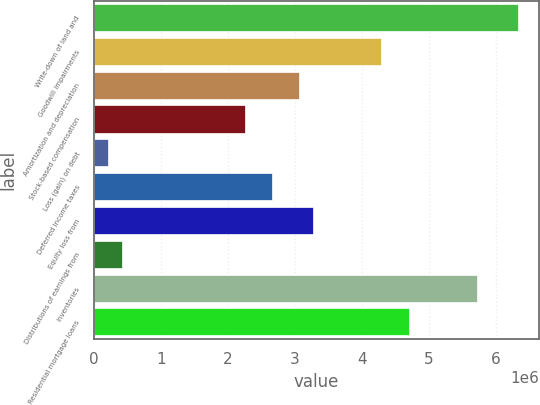Convert chart. <chart><loc_0><loc_0><loc_500><loc_500><bar_chart><fcel>Write-down of land and<fcel>Goodwill impairments<fcel>Amortization and depreciation<fcel>Stock-based compensation<fcel>Loss (gain) on debt<fcel>Deferred income taxes<fcel>Equity loss from<fcel>Distributions of earnings from<fcel>Inventories<fcel>Residential mortgage loans<nl><fcel>6.33174e+06<fcel>4.2893e+06<fcel>3.06384e+06<fcel>2.24686e+06<fcel>204423<fcel>2.65535e+06<fcel>3.26808e+06<fcel>408667<fcel>5.71901e+06<fcel>4.69779e+06<nl></chart> 